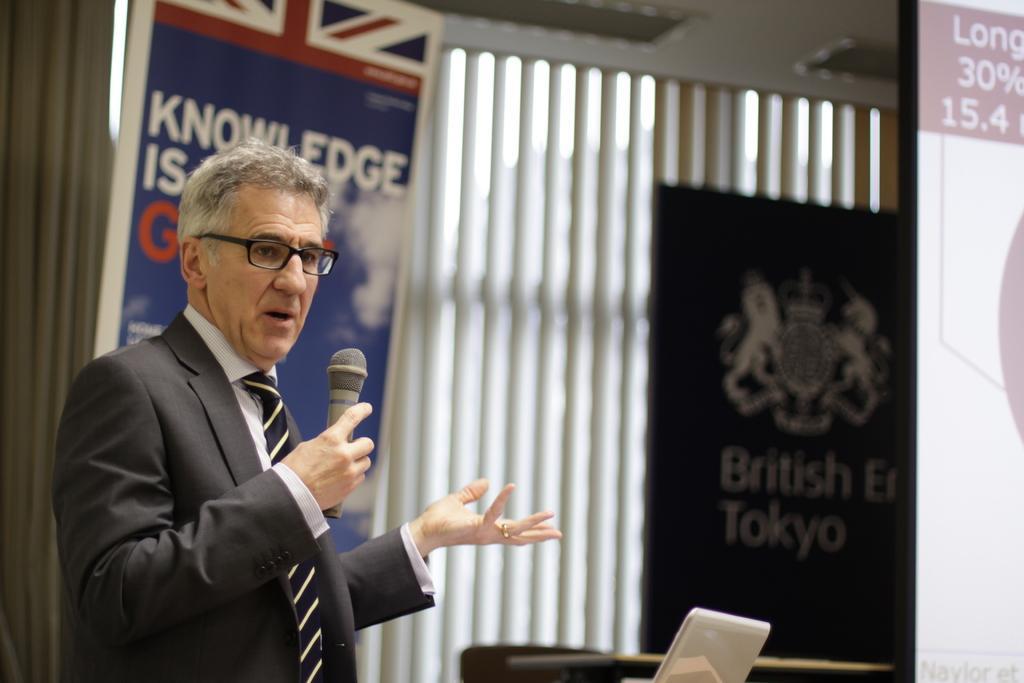Describe this image in one or two sentences. In this image we can see a person holding a mic and talking and in the background, we can see two boards with some text and on the right side of the image we can see a screen with some text. 